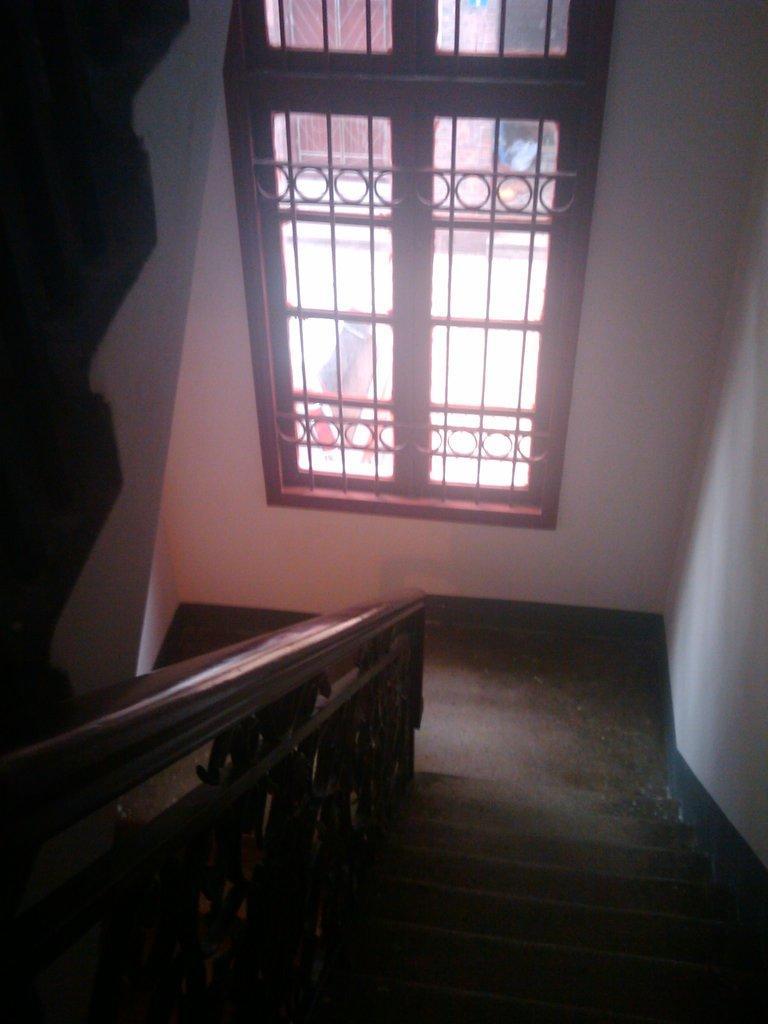How would you summarize this image in a sentence or two? In this image we can see the staircase, handrail, also we can see the windows, and the walls. 